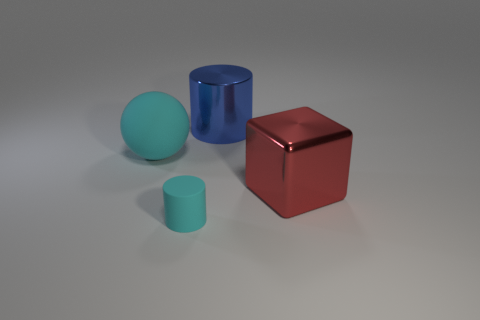Add 2 tiny purple rubber blocks. How many objects exist? 6 Subtract all balls. How many objects are left? 3 Subtract all red cylinders. Subtract all cyan spheres. How many cylinders are left? 2 Subtract all yellow balls. How many blue cylinders are left? 1 Subtract all tiny gray balls. Subtract all big blue cylinders. How many objects are left? 3 Add 3 blue cylinders. How many blue cylinders are left? 4 Add 4 tiny yellow objects. How many tiny yellow objects exist? 4 Subtract 0 yellow cubes. How many objects are left? 4 